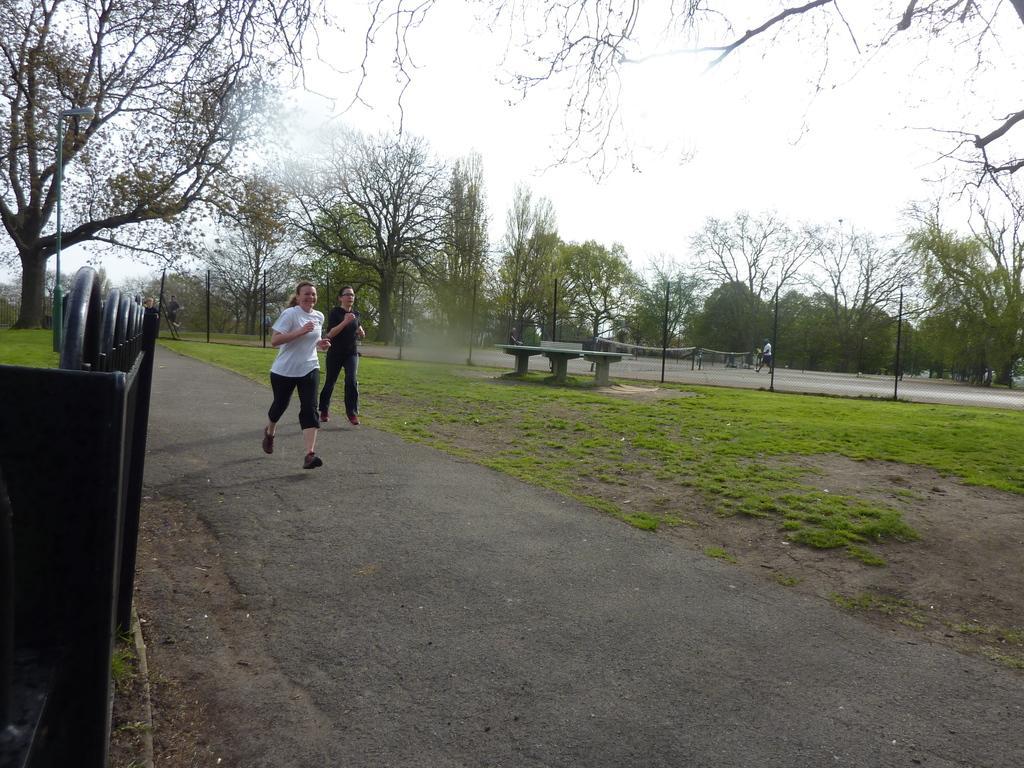Can you describe this image briefly? In this image we can see there are two ladies are running on the road. On the left side of the image there is a metal structure. In the background there are trees and sky. 